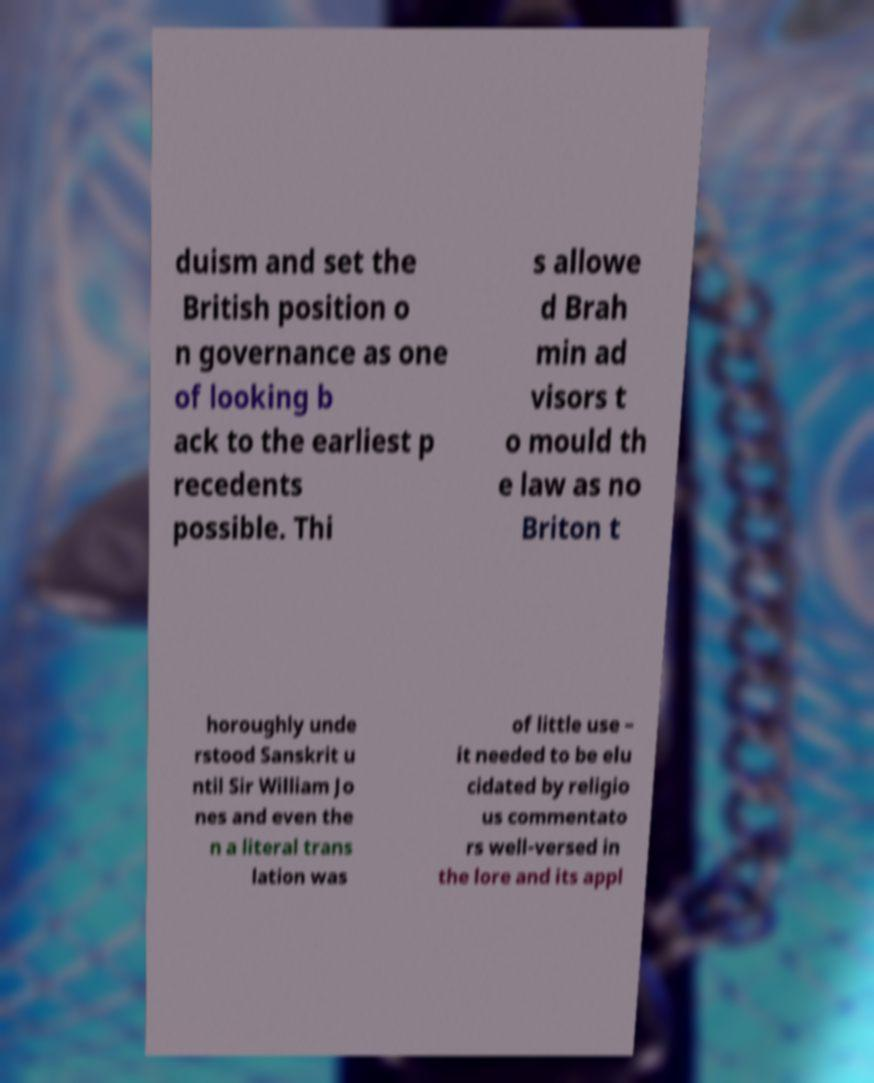For documentation purposes, I need the text within this image transcribed. Could you provide that? duism and set the British position o n governance as one of looking b ack to the earliest p recedents possible. Thi s allowe d Brah min ad visors t o mould th e law as no Briton t horoughly unde rstood Sanskrit u ntil Sir William Jo nes and even the n a literal trans lation was of little use – it needed to be elu cidated by religio us commentato rs well-versed in the lore and its appl 